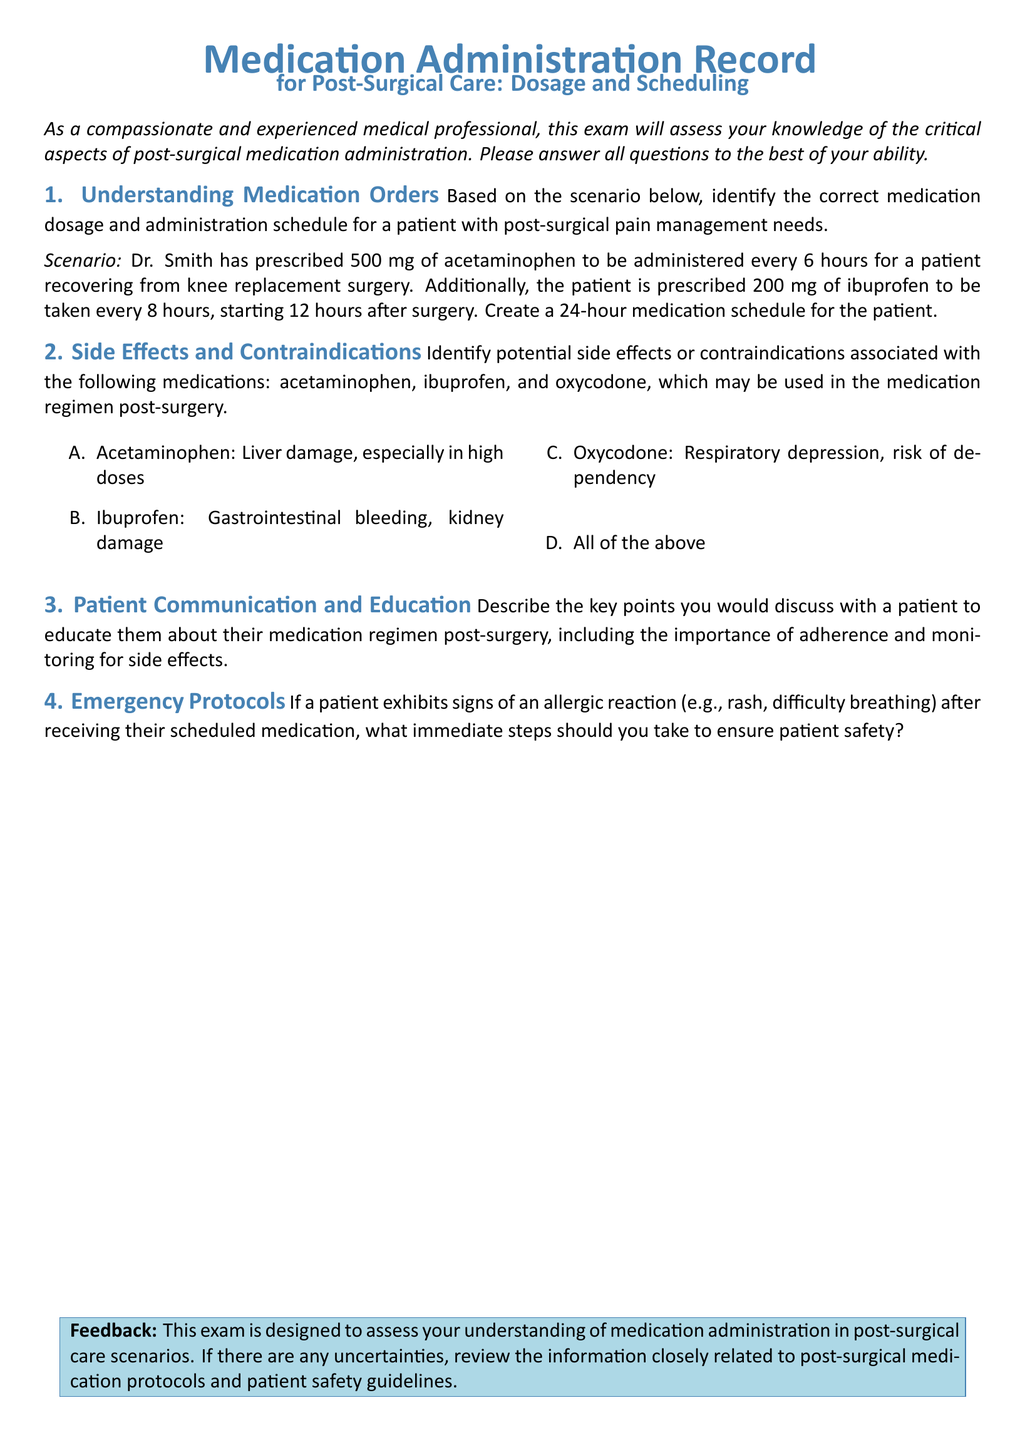What is the prescribed dosage of acetaminophen? The prescribed dosage for acetaminophen in the document is specified to be 500 mg, as mentioned in the medication order scenario.
Answer: 500 mg How often should acetaminophen be administered? The document states that acetaminophen should be administered every 6 hours based on the medication order scenario.
Answer: Every 6 hours What is the total duration covered in the medication schedule? The medication schedule created covers a 24-hour period following the post-surgical care protocol outlined in the document.
Answer: 24 hours What side effect is associated with ibuprofen? According to the document, one potential side effect of ibuprofen is gastrointestinal bleeding, as listed under the side effects section.
Answer: Gastrointestinal bleeding What step should be taken if a patient exhibits signs of an allergic reaction? The document suggests that immediate steps should be taken to ensure patient safety, indicating the importance of recognizing allergic reactions in a post-surgical setting.
Answer: Ensure patient safety Which medication carries a risk of dependency? The document highlights that oxycodone is associated with the risk of dependency in the context of post-surgical medication administration.
Answer: Oxycodone Who prescribed the medications for the patient? The scenario mentioned in the document indicates that Dr. Smith prescribed the medications for the patient's post-surgical care.
Answer: Dr. Smith How long after surgery should ibuprofen be administered? The document specifies that ibuprofen should be taken every 8 hours, starting 12 hours after surgery as indicated in the medication order.
Answer: 12 hours after surgery What is the color used for the title in the document? The title in the document is rendered in the color defined as 'medblue,' reflecting a calming and professional appearance in the layout.
Answer: medblue 